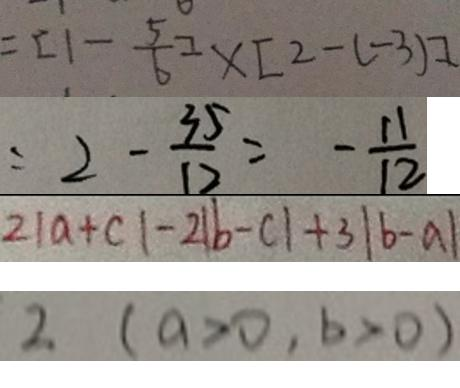Convert formula to latex. <formula><loc_0><loc_0><loc_500><loc_500>= [ 1 - \frac { 5 } { 6 } ] \times [ 2 - ( - 3 ) ] 
 = 2 - \frac { 3 5 } { 1 2 } = - \frac { 1 1 } { 1 2 } 
 2 \vert a + c \vert - 2 \vert b - c \vert + 3 \vert b - a \vert 
 2 ( a > 0 , b > 0 )</formula> 